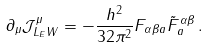<formula> <loc_0><loc_0><loc_500><loc_500>\partial _ { \mu } \mathcal { J } ^ { \mu } _ { L _ { E } W } = - \frac { h ^ { 2 } } { 3 2 \pi ^ { 2 } } F _ { \alpha \beta a } \tilde { F } ^ { \alpha \beta } _ { a } \, .</formula> 